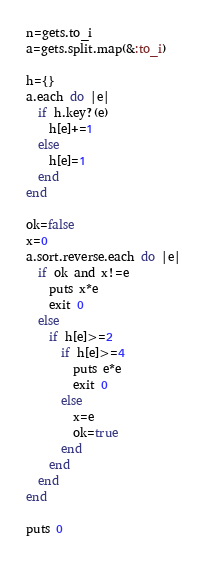Convert code to text. <code><loc_0><loc_0><loc_500><loc_500><_Ruby_>n=gets.to_i
a=gets.split.map(&:to_i)

h={}
a.each do |e|
  if h.key?(e)
    h[e]+=1
  else
    h[e]=1
  end
end

ok=false
x=0
a.sort.reverse.each do |e|
  if ok and x!=e
    puts x*e
    exit 0
  else
    if h[e]>=2
      if h[e]>=4
        puts e*e
        exit 0
      else
        x=e
        ok=true
      end
    end
  end
end

puts 0</code> 